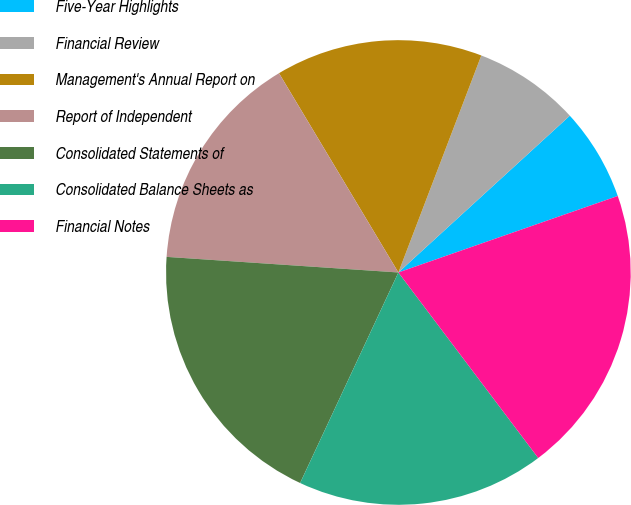<chart> <loc_0><loc_0><loc_500><loc_500><pie_chart><fcel>Five-Year Highlights<fcel>Financial Review<fcel>Management's Annual Report on<fcel>Report of Independent<fcel>Consolidated Statements of<fcel>Consolidated Balance Sheets as<fcel>Financial Notes<nl><fcel>6.45%<fcel>7.4%<fcel>14.4%<fcel>15.34%<fcel>19.12%<fcel>17.23%<fcel>20.06%<nl></chart> 